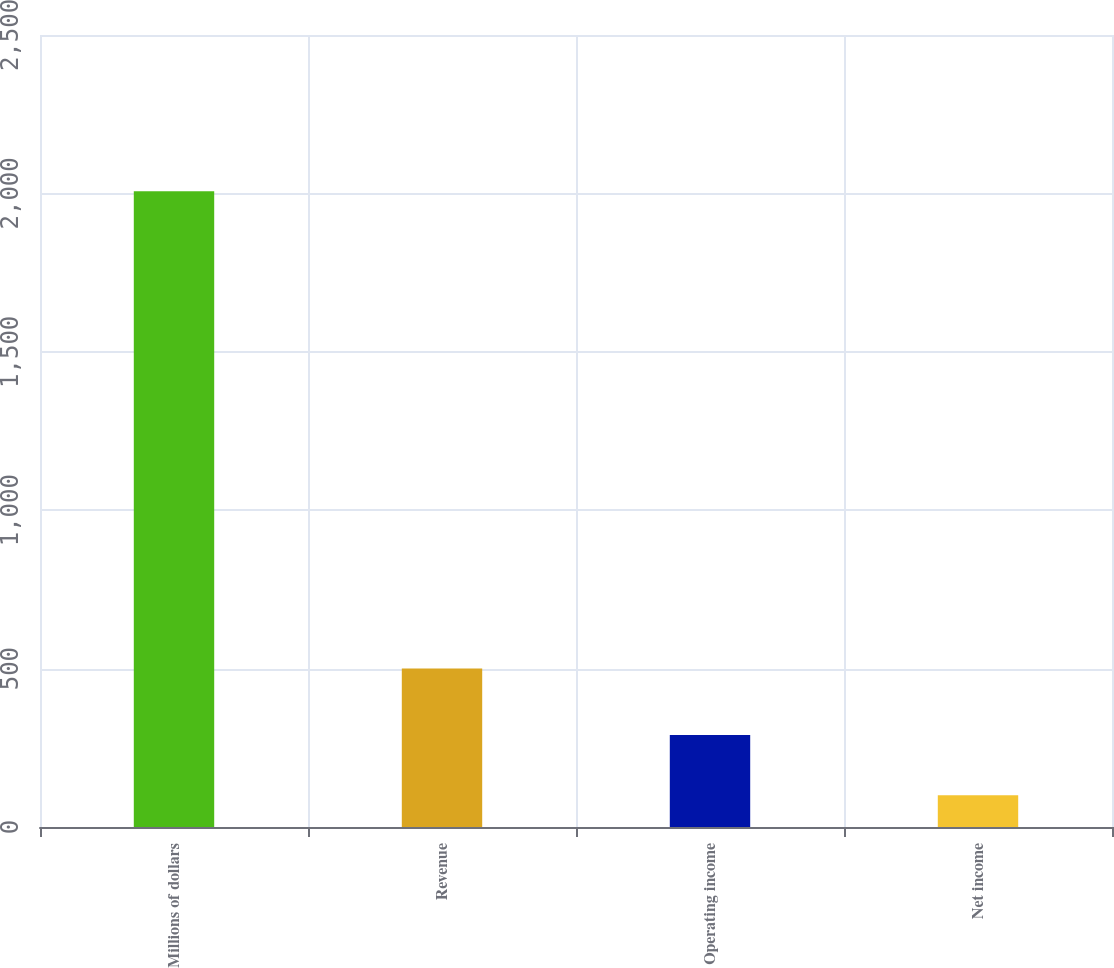Convert chart. <chart><loc_0><loc_0><loc_500><loc_500><bar_chart><fcel>Millions of dollars<fcel>Revenue<fcel>Operating income<fcel>Net income<nl><fcel>2007<fcel>500<fcel>290.7<fcel>100<nl></chart> 